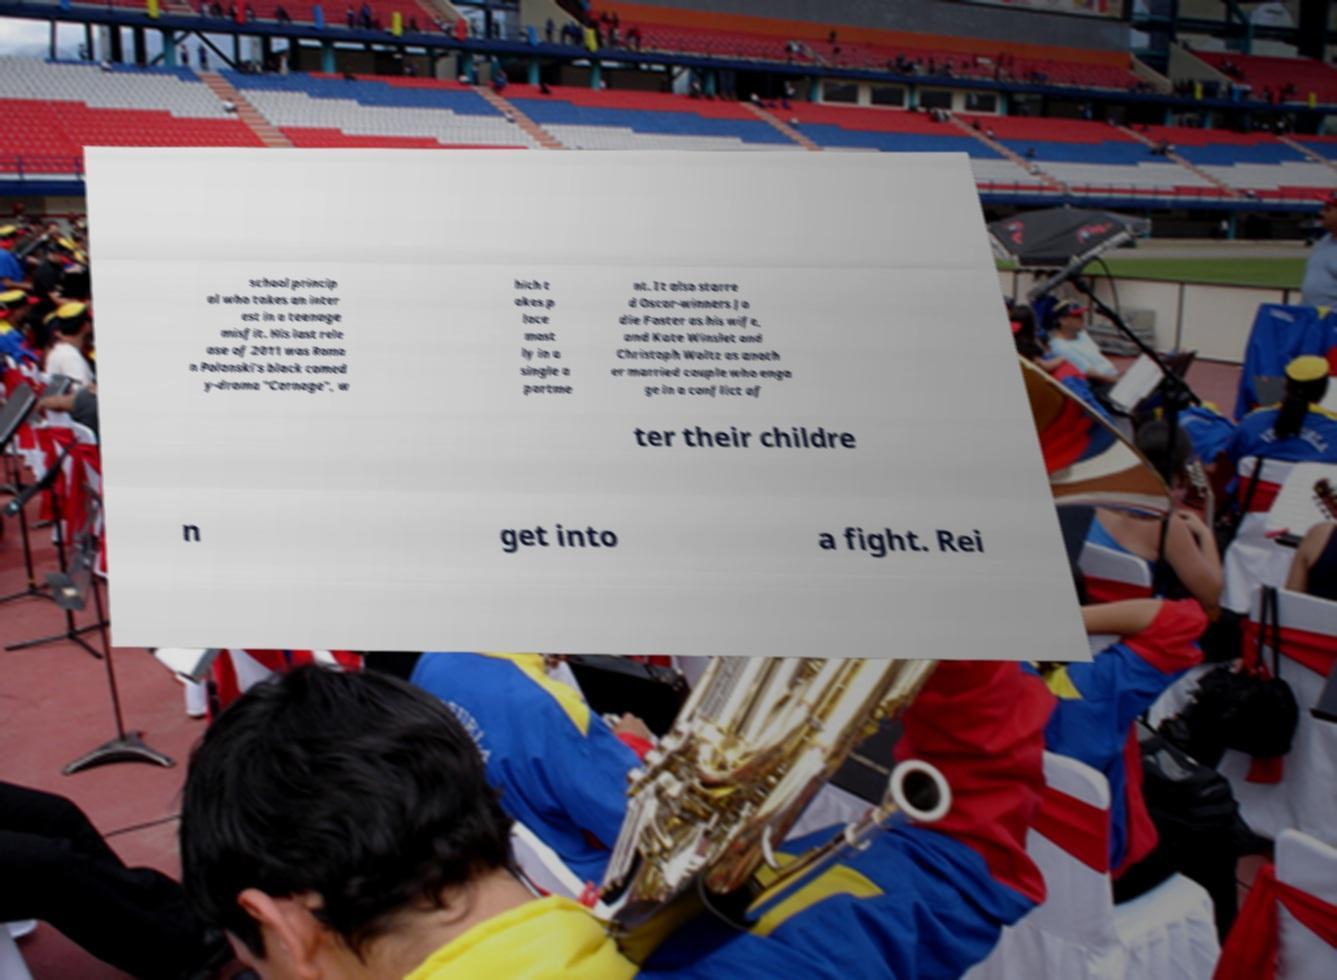What messages or text are displayed in this image? I need them in a readable, typed format. school princip al who takes an inter est in a teenage misfit. His last rele ase of 2011 was Roma n Polanski's black comed y-drama "Carnage", w hich t akes p lace most ly in a single a partme nt. It also starre d Oscar-winners Jo die Foster as his wife, and Kate Winslet and Christoph Waltz as anoth er married couple who enga ge in a conflict af ter their childre n get into a fight. Rei 